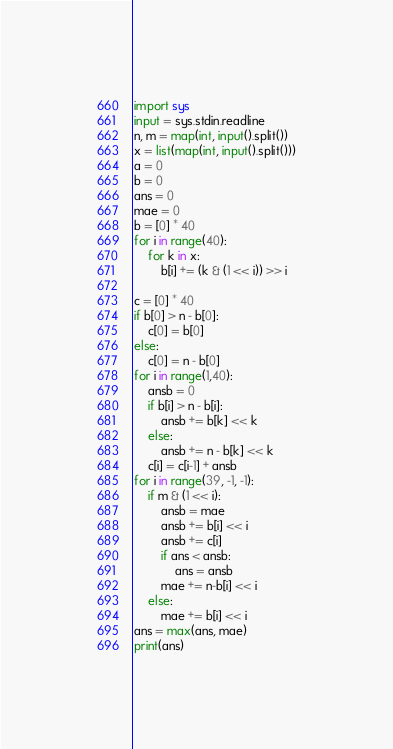Convert code to text. <code><loc_0><loc_0><loc_500><loc_500><_Python_>import sys
input = sys.stdin.readline
n, m = map(int, input().split())
x = list(map(int, input().split()))
a = 0
b = 0
ans = 0
mae = 0
b = [0] * 40
for i in range(40):
    for k in x:
        b[i] += (k & (1 << i)) >> i

c = [0] * 40
if b[0] > n - b[0]:
    c[0] = b[0]
else:
    c[0] = n - b[0]
for i in range(1,40):
    ansb = 0
    if b[i] > n - b[i]:
        ansb += b[k] << k
    else:
        ansb += n - b[k] << k
    c[i] = c[i-1] + ansb
for i in range(39, -1, -1):
    if m & (1 << i):
        ansb = mae
        ansb += b[i] << i
        ansb += c[i]
        if ans < ansb:
            ans = ansb
        mae += n-b[i] << i
    else:
        mae += b[i] << i
ans = max(ans, mae)
print(ans)
</code> 